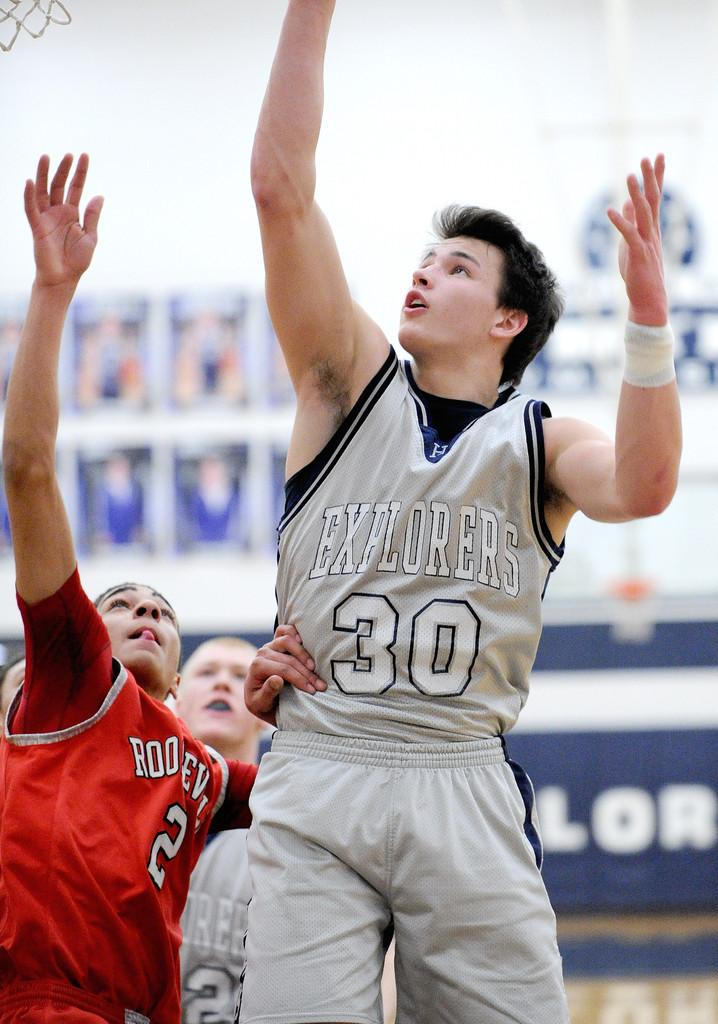<image>
Summarize the visual content of the image. Two young men, one playing basketball for the Explorers, are reaching high into the air, at a basketball net. 